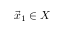Convert formula to latex. <formula><loc_0><loc_0><loc_500><loc_500>{ \vec { x } } _ { 1 } \in X</formula> 